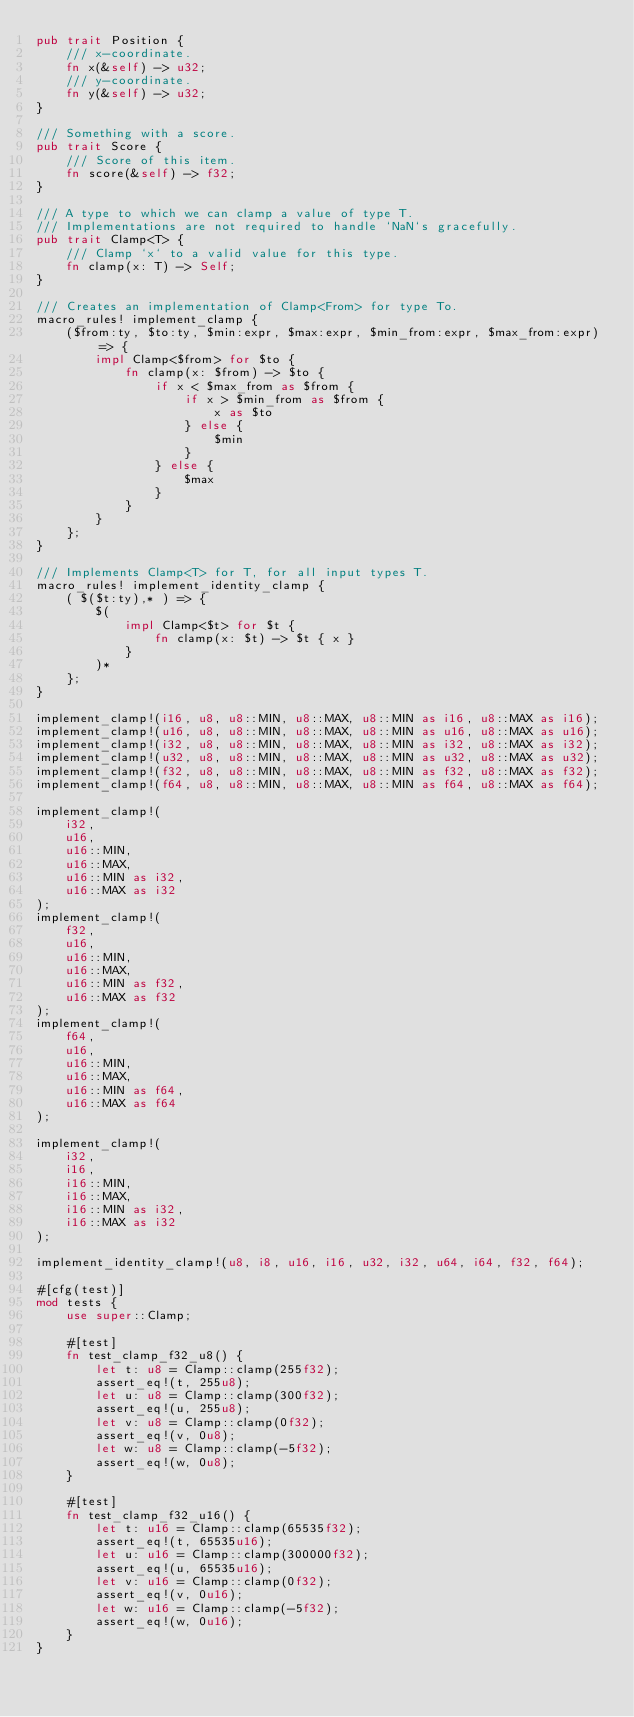<code> <loc_0><loc_0><loc_500><loc_500><_Rust_>pub trait Position {
    /// x-coordinate.
    fn x(&self) -> u32;
    /// y-coordinate.
    fn y(&self) -> u32;
}

/// Something with a score.
pub trait Score {
    /// Score of this item.
    fn score(&self) -> f32;
}

/// A type to which we can clamp a value of type T.
/// Implementations are not required to handle `NaN`s gracefully.
pub trait Clamp<T> {
    /// Clamp `x` to a valid value for this type.
    fn clamp(x: T) -> Self;
}

/// Creates an implementation of Clamp<From> for type To.
macro_rules! implement_clamp {
    ($from:ty, $to:ty, $min:expr, $max:expr, $min_from:expr, $max_from:expr) => {
        impl Clamp<$from> for $to {
            fn clamp(x: $from) -> $to {
                if x < $max_from as $from {
                    if x > $min_from as $from {
                        x as $to
                    } else {
                        $min
                    }
                } else {
                    $max
                }
            }
        }
    };
}

/// Implements Clamp<T> for T, for all input types T.
macro_rules! implement_identity_clamp {
    ( $($t:ty),* ) => {
        $(
            impl Clamp<$t> for $t {
                fn clamp(x: $t) -> $t { x }
            }
        )*
    };
}

implement_clamp!(i16, u8, u8::MIN, u8::MAX, u8::MIN as i16, u8::MAX as i16);
implement_clamp!(u16, u8, u8::MIN, u8::MAX, u8::MIN as u16, u8::MAX as u16);
implement_clamp!(i32, u8, u8::MIN, u8::MAX, u8::MIN as i32, u8::MAX as i32);
implement_clamp!(u32, u8, u8::MIN, u8::MAX, u8::MIN as u32, u8::MAX as u32);
implement_clamp!(f32, u8, u8::MIN, u8::MAX, u8::MIN as f32, u8::MAX as f32);
implement_clamp!(f64, u8, u8::MIN, u8::MAX, u8::MIN as f64, u8::MAX as f64);

implement_clamp!(
    i32,
    u16,
    u16::MIN,
    u16::MAX,
    u16::MIN as i32,
    u16::MAX as i32
);
implement_clamp!(
    f32,
    u16,
    u16::MIN,
    u16::MAX,
    u16::MIN as f32,
    u16::MAX as f32
);
implement_clamp!(
    f64,
    u16,
    u16::MIN,
    u16::MAX,
    u16::MIN as f64,
    u16::MAX as f64
);

implement_clamp!(
    i32,
    i16,
    i16::MIN,
    i16::MAX,
    i16::MIN as i32,
    i16::MAX as i32
);

implement_identity_clamp!(u8, i8, u16, i16, u32, i32, u64, i64, f32, f64);

#[cfg(test)]
mod tests {
    use super::Clamp;

    #[test]
    fn test_clamp_f32_u8() {
        let t: u8 = Clamp::clamp(255f32);
        assert_eq!(t, 255u8);
        let u: u8 = Clamp::clamp(300f32);
        assert_eq!(u, 255u8);
        let v: u8 = Clamp::clamp(0f32);
        assert_eq!(v, 0u8);
        let w: u8 = Clamp::clamp(-5f32);
        assert_eq!(w, 0u8);
    }

    #[test]
    fn test_clamp_f32_u16() {
        let t: u16 = Clamp::clamp(65535f32);
        assert_eq!(t, 65535u16);
        let u: u16 = Clamp::clamp(300000f32);
        assert_eq!(u, 65535u16);
        let v: u16 = Clamp::clamp(0f32);
        assert_eq!(v, 0u16);
        let w: u16 = Clamp::clamp(-5f32);
        assert_eq!(w, 0u16);
    }
}
</code> 